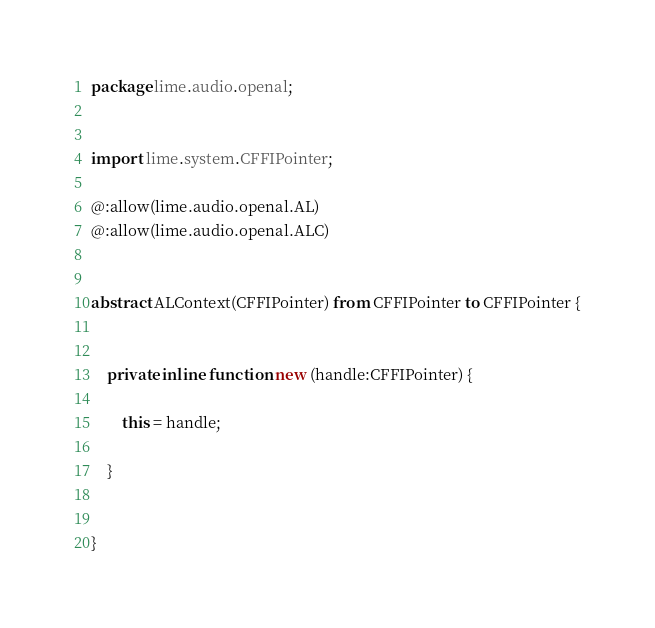Convert code to text. <code><loc_0><loc_0><loc_500><loc_500><_Haxe_>package lime.audio.openal;


import lime.system.CFFIPointer;

@:allow(lime.audio.openal.AL)
@:allow(lime.audio.openal.ALC)


abstract ALContext(CFFIPointer) from CFFIPointer to CFFIPointer {
	
	
	private inline function new (handle:CFFIPointer) {
		
		this = handle;
		
	}
	
	
}</code> 